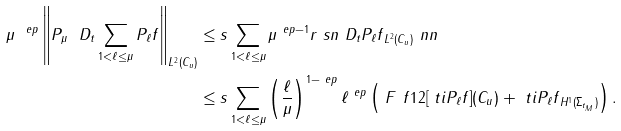<formula> <loc_0><loc_0><loc_500><loc_500>\mu ^ { \ e p } \left \| \sl P _ { \mu } \ D _ { t } \sum _ { 1 < \ell \leq \mu } P _ { \ell } f \right \| _ { L ^ { 2 } ( C _ { u } ) } & \leq s \sum _ { 1 < \ell \leq \mu } \mu ^ { \ e p - 1 } \| r \ s n \ D _ { t } P _ { \ell } f \| _ { L ^ { 2 } ( C _ { u } ) } \ n n \\ & \leq s \sum _ { 1 < \ell \leq \mu } \left ( \frac { \ell } { \mu } \right ) ^ { 1 - \ e p } \ell ^ { \ e p } \left ( \ F ^ { \ } f 1 2 [ \ t i P _ { \ell } f ] ( C _ { u } ) + \| \ t i P _ { \ell } f \| _ { H ^ { 1 } ( \Sigma _ { t _ { M } } ) } \right ) .</formula> 